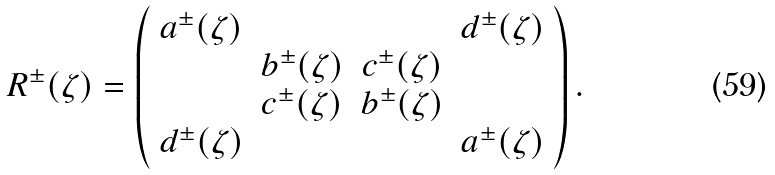<formula> <loc_0><loc_0><loc_500><loc_500>R ^ { \pm } ( \zeta ) = \left ( \begin{array} { c c c c } a ^ { \pm } ( \zeta ) & & & d ^ { \pm } ( \zeta ) \\ & b ^ { \pm } ( \zeta ) & c ^ { \pm } ( \zeta ) & \\ & c ^ { \pm } ( \zeta ) & b ^ { \pm } ( \zeta ) & \\ d ^ { \pm } ( \zeta ) & & & a ^ { \pm } ( \zeta ) \end{array} \right ) .</formula> 